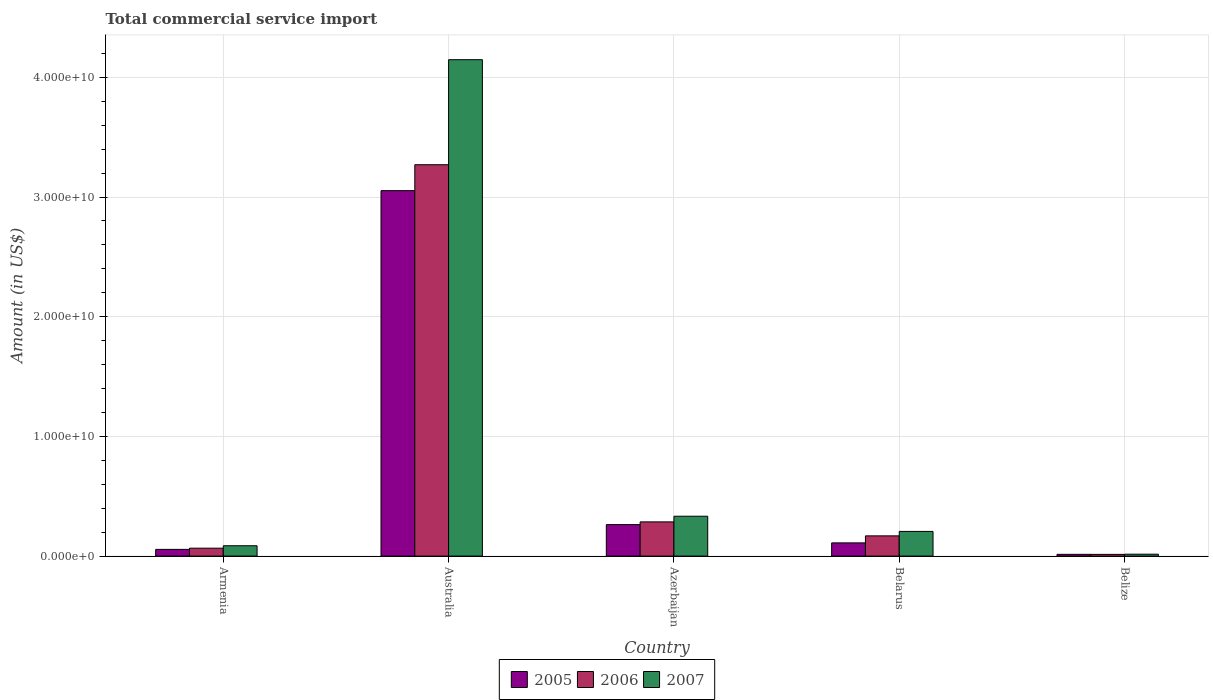How many different coloured bars are there?
Offer a very short reply. 3. How many groups of bars are there?
Keep it short and to the point. 5. How many bars are there on the 2nd tick from the left?
Your response must be concise. 3. How many bars are there on the 2nd tick from the right?
Your answer should be compact. 3. What is the label of the 1st group of bars from the left?
Offer a very short reply. Armenia. In how many cases, is the number of bars for a given country not equal to the number of legend labels?
Make the answer very short. 0. What is the total commercial service import in 2006 in Belarus?
Ensure brevity in your answer.  1.69e+09. Across all countries, what is the maximum total commercial service import in 2006?
Make the answer very short. 3.27e+1. Across all countries, what is the minimum total commercial service import in 2007?
Give a very brief answer. 1.59e+08. In which country was the total commercial service import in 2006 maximum?
Your answer should be very brief. Australia. In which country was the total commercial service import in 2007 minimum?
Offer a terse response. Belize. What is the total total commercial service import in 2005 in the graph?
Give a very brief answer. 3.50e+1. What is the difference between the total commercial service import in 2007 in Armenia and that in Belarus?
Provide a succinct answer. -1.20e+09. What is the difference between the total commercial service import in 2006 in Belize and the total commercial service import in 2005 in Belarus?
Provide a succinct answer. -9.61e+08. What is the average total commercial service import in 2006 per country?
Keep it short and to the point. 7.61e+09. What is the difference between the total commercial service import of/in 2005 and total commercial service import of/in 2007 in Australia?
Your answer should be compact. -1.09e+1. What is the ratio of the total commercial service import in 2006 in Armenia to that in Azerbaijan?
Your answer should be very brief. 0.23. Is the difference between the total commercial service import in 2005 in Armenia and Belize greater than the difference between the total commercial service import in 2007 in Armenia and Belize?
Provide a succinct answer. No. What is the difference between the highest and the second highest total commercial service import in 2006?
Your answer should be compact. 2.98e+1. What is the difference between the highest and the lowest total commercial service import in 2006?
Give a very brief answer. 3.26e+1. In how many countries, is the total commercial service import in 2005 greater than the average total commercial service import in 2005 taken over all countries?
Offer a very short reply. 1. What does the 1st bar from the right in Belarus represents?
Your answer should be compact. 2007. Is it the case that in every country, the sum of the total commercial service import in 2005 and total commercial service import in 2006 is greater than the total commercial service import in 2007?
Ensure brevity in your answer.  Yes. Are all the bars in the graph horizontal?
Offer a terse response. No. What is the difference between two consecutive major ticks on the Y-axis?
Offer a terse response. 1.00e+1. Are the values on the major ticks of Y-axis written in scientific E-notation?
Offer a very short reply. Yes. Does the graph contain any zero values?
Offer a terse response. No. Does the graph contain grids?
Ensure brevity in your answer.  Yes. Where does the legend appear in the graph?
Keep it short and to the point. Bottom center. What is the title of the graph?
Your answer should be compact. Total commercial service import. Does "1989" appear as one of the legend labels in the graph?
Your response must be concise. No. What is the Amount (in US$) of 2005 in Armenia?
Provide a short and direct response. 5.61e+08. What is the Amount (in US$) of 2006 in Armenia?
Make the answer very short. 6.62e+08. What is the Amount (in US$) in 2007 in Armenia?
Ensure brevity in your answer.  8.64e+08. What is the Amount (in US$) of 2005 in Australia?
Ensure brevity in your answer.  3.05e+1. What is the Amount (in US$) of 2006 in Australia?
Provide a succinct answer. 3.27e+1. What is the Amount (in US$) in 2007 in Australia?
Offer a very short reply. 4.15e+1. What is the Amount (in US$) in 2005 in Azerbaijan?
Provide a succinct answer. 2.63e+09. What is the Amount (in US$) of 2006 in Azerbaijan?
Ensure brevity in your answer.  2.86e+09. What is the Amount (in US$) of 2007 in Azerbaijan?
Give a very brief answer. 3.33e+09. What is the Amount (in US$) of 2005 in Belarus?
Your answer should be very brief. 1.10e+09. What is the Amount (in US$) in 2006 in Belarus?
Your response must be concise. 1.69e+09. What is the Amount (in US$) in 2007 in Belarus?
Provide a succinct answer. 2.06e+09. What is the Amount (in US$) in 2005 in Belize?
Offer a very short reply. 1.47e+08. What is the Amount (in US$) of 2006 in Belize?
Provide a succinct answer. 1.43e+08. What is the Amount (in US$) of 2007 in Belize?
Offer a terse response. 1.59e+08. Across all countries, what is the maximum Amount (in US$) in 2005?
Your answer should be very brief. 3.05e+1. Across all countries, what is the maximum Amount (in US$) of 2006?
Offer a very short reply. 3.27e+1. Across all countries, what is the maximum Amount (in US$) of 2007?
Your answer should be compact. 4.15e+1. Across all countries, what is the minimum Amount (in US$) in 2005?
Ensure brevity in your answer.  1.47e+08. Across all countries, what is the minimum Amount (in US$) in 2006?
Your answer should be very brief. 1.43e+08. Across all countries, what is the minimum Amount (in US$) in 2007?
Provide a succinct answer. 1.59e+08. What is the total Amount (in US$) of 2005 in the graph?
Give a very brief answer. 3.50e+1. What is the total Amount (in US$) of 2006 in the graph?
Give a very brief answer. 3.81e+1. What is the total Amount (in US$) of 2007 in the graph?
Provide a short and direct response. 4.79e+1. What is the difference between the Amount (in US$) in 2005 in Armenia and that in Australia?
Provide a succinct answer. -3.00e+1. What is the difference between the Amount (in US$) in 2006 in Armenia and that in Australia?
Your answer should be compact. -3.20e+1. What is the difference between the Amount (in US$) in 2007 in Armenia and that in Australia?
Your response must be concise. -4.06e+1. What is the difference between the Amount (in US$) of 2005 in Armenia and that in Azerbaijan?
Give a very brief answer. -2.07e+09. What is the difference between the Amount (in US$) of 2006 in Armenia and that in Azerbaijan?
Give a very brief answer. -2.20e+09. What is the difference between the Amount (in US$) of 2007 in Armenia and that in Azerbaijan?
Keep it short and to the point. -2.47e+09. What is the difference between the Amount (in US$) of 2005 in Armenia and that in Belarus?
Ensure brevity in your answer.  -5.43e+08. What is the difference between the Amount (in US$) in 2006 in Armenia and that in Belarus?
Ensure brevity in your answer.  -1.03e+09. What is the difference between the Amount (in US$) in 2007 in Armenia and that in Belarus?
Keep it short and to the point. -1.20e+09. What is the difference between the Amount (in US$) in 2005 in Armenia and that in Belize?
Give a very brief answer. 4.14e+08. What is the difference between the Amount (in US$) of 2006 in Armenia and that in Belize?
Your answer should be very brief. 5.19e+08. What is the difference between the Amount (in US$) of 2007 in Armenia and that in Belize?
Your answer should be compact. 7.05e+08. What is the difference between the Amount (in US$) of 2005 in Australia and that in Azerbaijan?
Keep it short and to the point. 2.79e+1. What is the difference between the Amount (in US$) in 2006 in Australia and that in Azerbaijan?
Provide a short and direct response. 2.98e+1. What is the difference between the Amount (in US$) in 2007 in Australia and that in Azerbaijan?
Make the answer very short. 3.81e+1. What is the difference between the Amount (in US$) of 2005 in Australia and that in Belarus?
Your answer should be very brief. 2.94e+1. What is the difference between the Amount (in US$) in 2006 in Australia and that in Belarus?
Your answer should be very brief. 3.10e+1. What is the difference between the Amount (in US$) of 2007 in Australia and that in Belarus?
Provide a succinct answer. 3.94e+1. What is the difference between the Amount (in US$) of 2005 in Australia and that in Belize?
Give a very brief answer. 3.04e+1. What is the difference between the Amount (in US$) of 2006 in Australia and that in Belize?
Make the answer very short. 3.26e+1. What is the difference between the Amount (in US$) of 2007 in Australia and that in Belize?
Your answer should be very brief. 4.13e+1. What is the difference between the Amount (in US$) in 2005 in Azerbaijan and that in Belarus?
Ensure brevity in your answer.  1.53e+09. What is the difference between the Amount (in US$) in 2006 in Azerbaijan and that in Belarus?
Your answer should be compact. 1.17e+09. What is the difference between the Amount (in US$) of 2007 in Azerbaijan and that in Belarus?
Your response must be concise. 1.27e+09. What is the difference between the Amount (in US$) in 2005 in Azerbaijan and that in Belize?
Keep it short and to the point. 2.48e+09. What is the difference between the Amount (in US$) of 2006 in Azerbaijan and that in Belize?
Make the answer very short. 2.72e+09. What is the difference between the Amount (in US$) in 2007 in Azerbaijan and that in Belize?
Give a very brief answer. 3.17e+09. What is the difference between the Amount (in US$) in 2005 in Belarus and that in Belize?
Your answer should be compact. 9.57e+08. What is the difference between the Amount (in US$) of 2006 in Belarus and that in Belize?
Your response must be concise. 1.55e+09. What is the difference between the Amount (in US$) of 2007 in Belarus and that in Belize?
Give a very brief answer. 1.90e+09. What is the difference between the Amount (in US$) of 2005 in Armenia and the Amount (in US$) of 2006 in Australia?
Provide a short and direct response. -3.21e+1. What is the difference between the Amount (in US$) of 2005 in Armenia and the Amount (in US$) of 2007 in Australia?
Offer a very short reply. -4.09e+1. What is the difference between the Amount (in US$) in 2006 in Armenia and the Amount (in US$) in 2007 in Australia?
Make the answer very short. -4.08e+1. What is the difference between the Amount (in US$) in 2005 in Armenia and the Amount (in US$) in 2006 in Azerbaijan?
Your answer should be compact. -2.30e+09. What is the difference between the Amount (in US$) of 2005 in Armenia and the Amount (in US$) of 2007 in Azerbaijan?
Ensure brevity in your answer.  -2.77e+09. What is the difference between the Amount (in US$) in 2006 in Armenia and the Amount (in US$) in 2007 in Azerbaijan?
Provide a short and direct response. -2.67e+09. What is the difference between the Amount (in US$) in 2005 in Armenia and the Amount (in US$) in 2006 in Belarus?
Offer a terse response. -1.13e+09. What is the difference between the Amount (in US$) in 2005 in Armenia and the Amount (in US$) in 2007 in Belarus?
Your response must be concise. -1.50e+09. What is the difference between the Amount (in US$) in 2006 in Armenia and the Amount (in US$) in 2007 in Belarus?
Keep it short and to the point. -1.40e+09. What is the difference between the Amount (in US$) in 2005 in Armenia and the Amount (in US$) in 2006 in Belize?
Your response must be concise. 4.18e+08. What is the difference between the Amount (in US$) in 2005 in Armenia and the Amount (in US$) in 2007 in Belize?
Make the answer very short. 4.02e+08. What is the difference between the Amount (in US$) of 2006 in Armenia and the Amount (in US$) of 2007 in Belize?
Provide a succinct answer. 5.03e+08. What is the difference between the Amount (in US$) of 2005 in Australia and the Amount (in US$) of 2006 in Azerbaijan?
Keep it short and to the point. 2.77e+1. What is the difference between the Amount (in US$) of 2005 in Australia and the Amount (in US$) of 2007 in Azerbaijan?
Provide a succinct answer. 2.72e+1. What is the difference between the Amount (in US$) in 2006 in Australia and the Amount (in US$) in 2007 in Azerbaijan?
Offer a very short reply. 2.94e+1. What is the difference between the Amount (in US$) of 2005 in Australia and the Amount (in US$) of 2006 in Belarus?
Provide a short and direct response. 2.88e+1. What is the difference between the Amount (in US$) of 2005 in Australia and the Amount (in US$) of 2007 in Belarus?
Ensure brevity in your answer.  2.85e+1. What is the difference between the Amount (in US$) in 2006 in Australia and the Amount (in US$) in 2007 in Belarus?
Ensure brevity in your answer.  3.06e+1. What is the difference between the Amount (in US$) of 2005 in Australia and the Amount (in US$) of 2006 in Belize?
Give a very brief answer. 3.04e+1. What is the difference between the Amount (in US$) in 2005 in Australia and the Amount (in US$) in 2007 in Belize?
Your answer should be very brief. 3.04e+1. What is the difference between the Amount (in US$) of 2006 in Australia and the Amount (in US$) of 2007 in Belize?
Provide a succinct answer. 3.25e+1. What is the difference between the Amount (in US$) in 2005 in Azerbaijan and the Amount (in US$) in 2006 in Belarus?
Keep it short and to the point. 9.40e+08. What is the difference between the Amount (in US$) in 2005 in Azerbaijan and the Amount (in US$) in 2007 in Belarus?
Provide a short and direct response. 5.68e+08. What is the difference between the Amount (in US$) of 2006 in Azerbaijan and the Amount (in US$) of 2007 in Belarus?
Provide a short and direct response. 7.97e+08. What is the difference between the Amount (in US$) of 2005 in Azerbaijan and the Amount (in US$) of 2006 in Belize?
Provide a succinct answer. 2.49e+09. What is the difference between the Amount (in US$) of 2005 in Azerbaijan and the Amount (in US$) of 2007 in Belize?
Ensure brevity in your answer.  2.47e+09. What is the difference between the Amount (in US$) of 2006 in Azerbaijan and the Amount (in US$) of 2007 in Belize?
Your response must be concise. 2.70e+09. What is the difference between the Amount (in US$) in 2005 in Belarus and the Amount (in US$) in 2006 in Belize?
Your response must be concise. 9.61e+08. What is the difference between the Amount (in US$) in 2005 in Belarus and the Amount (in US$) in 2007 in Belize?
Keep it short and to the point. 9.45e+08. What is the difference between the Amount (in US$) of 2006 in Belarus and the Amount (in US$) of 2007 in Belize?
Provide a succinct answer. 1.53e+09. What is the average Amount (in US$) of 2005 per country?
Your response must be concise. 7.00e+09. What is the average Amount (in US$) in 2006 per country?
Ensure brevity in your answer.  7.61e+09. What is the average Amount (in US$) in 2007 per country?
Your answer should be compact. 9.58e+09. What is the difference between the Amount (in US$) in 2005 and Amount (in US$) in 2006 in Armenia?
Ensure brevity in your answer.  -1.01e+08. What is the difference between the Amount (in US$) of 2005 and Amount (in US$) of 2007 in Armenia?
Provide a succinct answer. -3.03e+08. What is the difference between the Amount (in US$) in 2006 and Amount (in US$) in 2007 in Armenia?
Provide a short and direct response. -2.02e+08. What is the difference between the Amount (in US$) in 2005 and Amount (in US$) in 2006 in Australia?
Keep it short and to the point. -2.17e+09. What is the difference between the Amount (in US$) of 2005 and Amount (in US$) of 2007 in Australia?
Your answer should be very brief. -1.09e+1. What is the difference between the Amount (in US$) of 2006 and Amount (in US$) of 2007 in Australia?
Provide a succinct answer. -8.78e+09. What is the difference between the Amount (in US$) of 2005 and Amount (in US$) of 2006 in Azerbaijan?
Offer a very short reply. -2.28e+08. What is the difference between the Amount (in US$) in 2005 and Amount (in US$) in 2007 in Azerbaijan?
Keep it short and to the point. -7.00e+08. What is the difference between the Amount (in US$) of 2006 and Amount (in US$) of 2007 in Azerbaijan?
Provide a short and direct response. -4.72e+08. What is the difference between the Amount (in US$) of 2005 and Amount (in US$) of 2006 in Belarus?
Provide a succinct answer. -5.87e+08. What is the difference between the Amount (in US$) of 2005 and Amount (in US$) of 2007 in Belarus?
Your answer should be very brief. -9.58e+08. What is the difference between the Amount (in US$) in 2006 and Amount (in US$) in 2007 in Belarus?
Offer a very short reply. -3.72e+08. What is the difference between the Amount (in US$) of 2005 and Amount (in US$) of 2006 in Belize?
Offer a terse response. 3.89e+06. What is the difference between the Amount (in US$) of 2005 and Amount (in US$) of 2007 in Belize?
Make the answer very short. -1.18e+07. What is the difference between the Amount (in US$) of 2006 and Amount (in US$) of 2007 in Belize?
Give a very brief answer. -1.57e+07. What is the ratio of the Amount (in US$) in 2005 in Armenia to that in Australia?
Provide a succinct answer. 0.02. What is the ratio of the Amount (in US$) in 2006 in Armenia to that in Australia?
Keep it short and to the point. 0.02. What is the ratio of the Amount (in US$) in 2007 in Armenia to that in Australia?
Make the answer very short. 0.02. What is the ratio of the Amount (in US$) in 2005 in Armenia to that in Azerbaijan?
Your answer should be very brief. 0.21. What is the ratio of the Amount (in US$) in 2006 in Armenia to that in Azerbaijan?
Give a very brief answer. 0.23. What is the ratio of the Amount (in US$) of 2007 in Armenia to that in Azerbaijan?
Provide a short and direct response. 0.26. What is the ratio of the Amount (in US$) of 2005 in Armenia to that in Belarus?
Ensure brevity in your answer.  0.51. What is the ratio of the Amount (in US$) in 2006 in Armenia to that in Belarus?
Provide a succinct answer. 0.39. What is the ratio of the Amount (in US$) of 2007 in Armenia to that in Belarus?
Make the answer very short. 0.42. What is the ratio of the Amount (in US$) in 2005 in Armenia to that in Belize?
Provide a succinct answer. 3.81. What is the ratio of the Amount (in US$) of 2006 in Armenia to that in Belize?
Your response must be concise. 4.62. What is the ratio of the Amount (in US$) in 2007 in Armenia to that in Belize?
Make the answer very short. 5.44. What is the ratio of the Amount (in US$) of 2005 in Australia to that in Azerbaijan?
Keep it short and to the point. 11.61. What is the ratio of the Amount (in US$) of 2006 in Australia to that in Azerbaijan?
Offer a very short reply. 11.44. What is the ratio of the Amount (in US$) in 2007 in Australia to that in Azerbaijan?
Offer a very short reply. 12.45. What is the ratio of the Amount (in US$) of 2005 in Australia to that in Belarus?
Ensure brevity in your answer.  27.65. What is the ratio of the Amount (in US$) in 2006 in Australia to that in Belarus?
Offer a very short reply. 19.34. What is the ratio of the Amount (in US$) in 2007 in Australia to that in Belarus?
Offer a terse response. 20.11. What is the ratio of the Amount (in US$) of 2005 in Australia to that in Belize?
Offer a very short reply. 207.45. What is the ratio of the Amount (in US$) of 2006 in Australia to that in Belize?
Offer a very short reply. 228.19. What is the ratio of the Amount (in US$) in 2007 in Australia to that in Belize?
Make the answer very short. 260.86. What is the ratio of the Amount (in US$) of 2005 in Azerbaijan to that in Belarus?
Provide a succinct answer. 2.38. What is the ratio of the Amount (in US$) in 2006 in Azerbaijan to that in Belarus?
Ensure brevity in your answer.  1.69. What is the ratio of the Amount (in US$) in 2007 in Azerbaijan to that in Belarus?
Provide a succinct answer. 1.61. What is the ratio of the Amount (in US$) in 2005 in Azerbaijan to that in Belize?
Make the answer very short. 17.87. What is the ratio of the Amount (in US$) of 2006 in Azerbaijan to that in Belize?
Keep it short and to the point. 19.95. What is the ratio of the Amount (in US$) of 2007 in Azerbaijan to that in Belize?
Make the answer very short. 20.95. What is the ratio of the Amount (in US$) in 2005 in Belarus to that in Belize?
Keep it short and to the point. 7.5. What is the ratio of the Amount (in US$) of 2006 in Belarus to that in Belize?
Offer a terse response. 11.8. What is the ratio of the Amount (in US$) in 2007 in Belarus to that in Belize?
Keep it short and to the point. 12.97. What is the difference between the highest and the second highest Amount (in US$) in 2005?
Ensure brevity in your answer.  2.79e+1. What is the difference between the highest and the second highest Amount (in US$) of 2006?
Keep it short and to the point. 2.98e+1. What is the difference between the highest and the second highest Amount (in US$) of 2007?
Make the answer very short. 3.81e+1. What is the difference between the highest and the lowest Amount (in US$) in 2005?
Your answer should be very brief. 3.04e+1. What is the difference between the highest and the lowest Amount (in US$) in 2006?
Give a very brief answer. 3.26e+1. What is the difference between the highest and the lowest Amount (in US$) in 2007?
Your answer should be compact. 4.13e+1. 